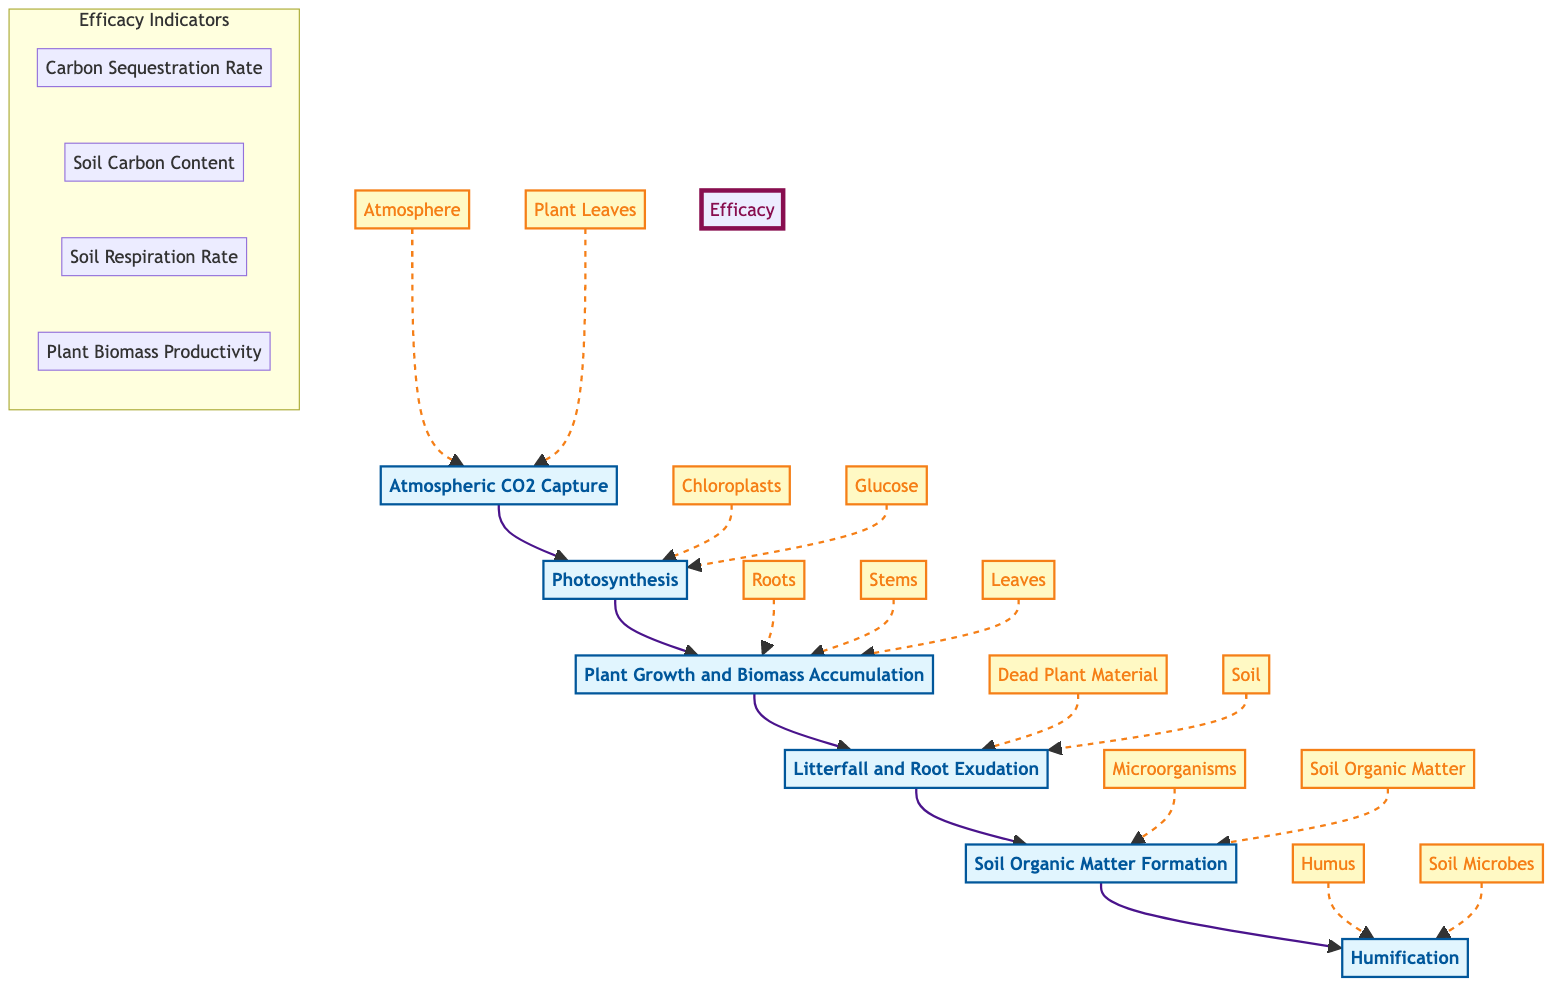What is the first step in the carbon sequestration process? The first step is "Atmospheric CO2 Capture," which is shown at the bottom of the flow chart. This step indicates that CO2 is absorbed from the atmosphere by plants during photosynthesis.
Answer: Atmospheric CO2 Capture How many main steps are there in the carbon sequestration process? The diagram shows a total of six main steps in the carbon sequestration process, depicted from bottom to top.
Answer: Six What is the eighth entity mentioned in the diagram? The entities are listed in conjunction with each step; it includes "Soil." This is the eighth entity when counted from the top of the flow chart.
Answer: Soil What entity is associated with the process of photosynthesis? The entities associated with "Photosynthesis" include "Chloroplasts" and "Glucose." It's specifically related to the organelles where photosynthesis occurs.
Answer: Chloroplasts Which step involves decomposition of plant material? The step that involves decomposition is "Soil Organic Matter Formation," where microorganisms break down plant material into soil organic matter.
Answer: Soil Organic Matter Formation What is the last process in the sequence? The last process in the sequence, shown at the top of the flow chart, is "Humification," which indicates the formation of stable humus that stores carbon long-term.
Answer: Humification Which efficacy indicator relates to the efficiency of carbon storage? The efficacy indicator that relates to carbon storage efficiency is "Soil Carbon Content." It is a crucial measure for understanding how much carbon has been sequestered in the soil.
Answer: Soil Carbon Content Identify the relationship between "Litterfall and Root Exudation" and "Soil Organic Matter Formation." "Litterfall and Root Exudation" leads to "Soil Organic Matter Formation," indicating that decaying plant matter adds carbon to the soil, which is then decomposed into organic matter.
Answer: Leads to How many distinct entities are connected to "Plant Growth and Biomass Accumulation"? "Plant Growth and Biomass Accumulation" is connected to three distinct entities: "Roots," "Stems," and "Leaves," all of which are parts of the plant where biomass is accumulated.
Answer: Three What is the primary focus of "Humification" in the carbon sequestration process? The primary focus of "Humification" is the further decomposition of organic matter to form stable humus, which is key for long-term carbon storage in the soil.
Answer: Stable humus 